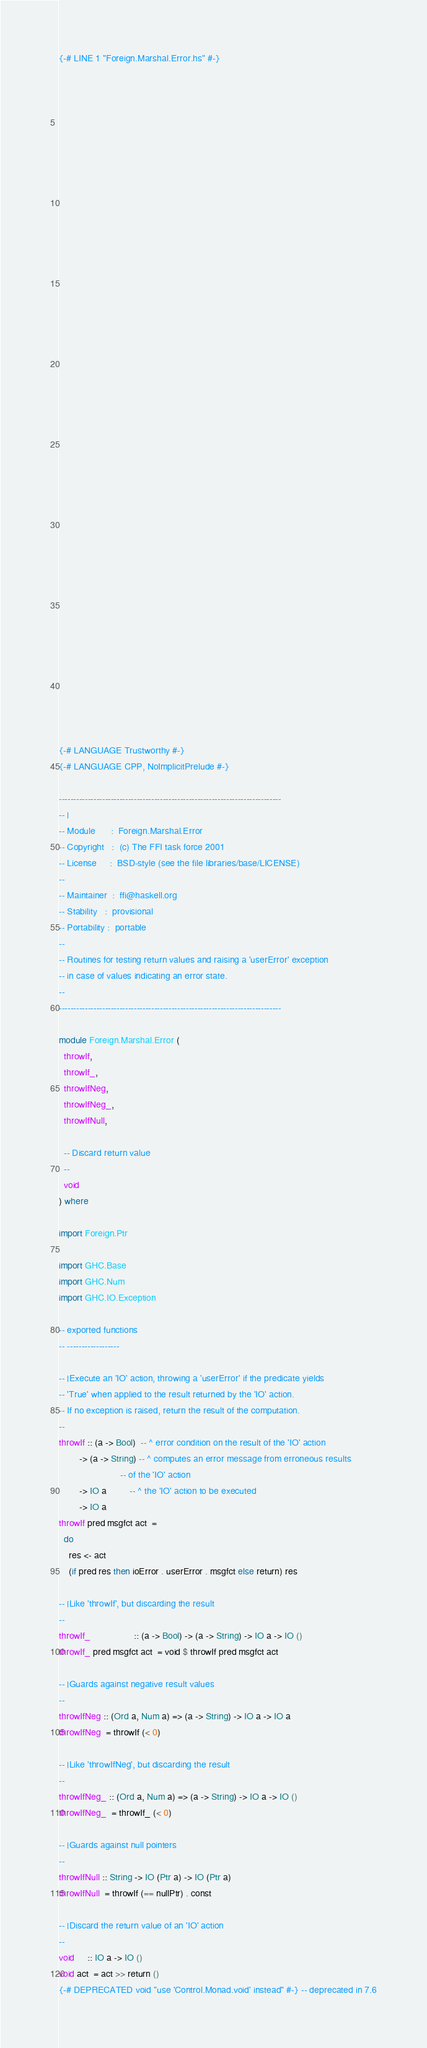Convert code to text. <code><loc_0><loc_0><loc_500><loc_500><_Haskell_>{-# LINE 1 "Foreign.Marshal.Error.hs" #-}










































{-# LANGUAGE Trustworthy #-}
{-# LANGUAGE CPP, NoImplicitPrelude #-}

-----------------------------------------------------------------------------
-- |
-- Module      :  Foreign.Marshal.Error
-- Copyright   :  (c) The FFI task force 2001
-- License     :  BSD-style (see the file libraries/base/LICENSE)
-- 
-- Maintainer  :  ffi@haskell.org
-- Stability   :  provisional
-- Portability :  portable
--
-- Routines for testing return values and raising a 'userError' exception
-- in case of values indicating an error state.
--
-----------------------------------------------------------------------------

module Foreign.Marshal.Error (
  throwIf,
  throwIf_,
  throwIfNeg,
  throwIfNeg_,
  throwIfNull,

  -- Discard return value
  --
  void
) where

import Foreign.Ptr

import GHC.Base
import GHC.Num
import GHC.IO.Exception

-- exported functions
-- ------------------

-- |Execute an 'IO' action, throwing a 'userError' if the predicate yields
-- 'True' when applied to the result returned by the 'IO' action.
-- If no exception is raised, return the result of the computation.
--
throwIf :: (a -> Bool)  -- ^ error condition on the result of the 'IO' action
        -> (a -> String) -- ^ computes an error message from erroneous results
                        -- of the 'IO' action
        -> IO a         -- ^ the 'IO' action to be executed
        -> IO a
throwIf pred msgfct act  = 
  do
    res <- act
    (if pred res then ioError . userError . msgfct else return) res

-- |Like 'throwIf', but discarding the result
--
throwIf_                 :: (a -> Bool) -> (a -> String) -> IO a -> IO ()
throwIf_ pred msgfct act  = void $ throwIf pred msgfct act

-- |Guards against negative result values
--
throwIfNeg :: (Ord a, Num a) => (a -> String) -> IO a -> IO a
throwIfNeg  = throwIf (< 0)

-- |Like 'throwIfNeg', but discarding the result
--
throwIfNeg_ :: (Ord a, Num a) => (a -> String) -> IO a -> IO ()
throwIfNeg_  = throwIf_ (< 0)

-- |Guards against null pointers
--
throwIfNull :: String -> IO (Ptr a) -> IO (Ptr a)
throwIfNull  = throwIf (== nullPtr) . const

-- |Discard the return value of an 'IO' action
--
void     :: IO a -> IO ()
void act  = act >> return ()
{-# DEPRECATED void "use 'Control.Monad.void' instead" #-} -- deprecated in 7.6
</code> 